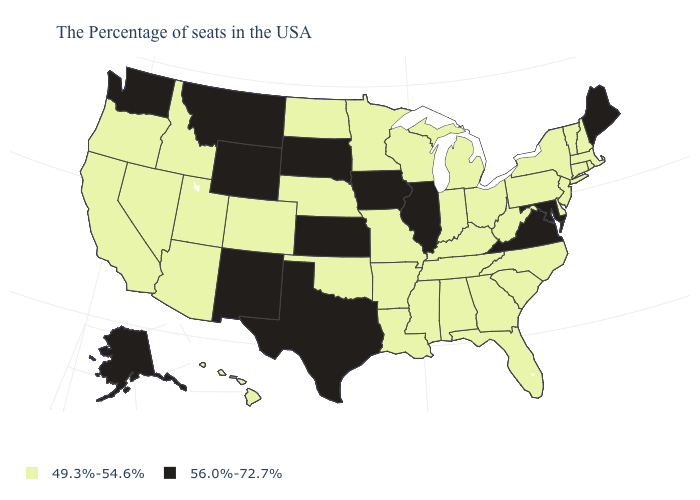What is the lowest value in states that border Kansas?
Short answer required. 49.3%-54.6%. Which states have the lowest value in the USA?
Give a very brief answer. Massachusetts, Rhode Island, New Hampshire, Vermont, Connecticut, New York, New Jersey, Delaware, Pennsylvania, North Carolina, South Carolina, West Virginia, Ohio, Florida, Georgia, Michigan, Kentucky, Indiana, Alabama, Tennessee, Wisconsin, Mississippi, Louisiana, Missouri, Arkansas, Minnesota, Nebraska, Oklahoma, North Dakota, Colorado, Utah, Arizona, Idaho, Nevada, California, Oregon, Hawaii. What is the value of Rhode Island?
Keep it brief. 49.3%-54.6%. Does Wyoming have the highest value in the West?
Answer briefly. Yes. Does Wisconsin have the highest value in the USA?
Concise answer only. No. Does the first symbol in the legend represent the smallest category?
Write a very short answer. Yes. Name the states that have a value in the range 56.0%-72.7%?
Answer briefly. Maine, Maryland, Virginia, Illinois, Iowa, Kansas, Texas, South Dakota, Wyoming, New Mexico, Montana, Washington, Alaska. Name the states that have a value in the range 49.3%-54.6%?
Answer briefly. Massachusetts, Rhode Island, New Hampshire, Vermont, Connecticut, New York, New Jersey, Delaware, Pennsylvania, North Carolina, South Carolina, West Virginia, Ohio, Florida, Georgia, Michigan, Kentucky, Indiana, Alabama, Tennessee, Wisconsin, Mississippi, Louisiana, Missouri, Arkansas, Minnesota, Nebraska, Oklahoma, North Dakota, Colorado, Utah, Arizona, Idaho, Nevada, California, Oregon, Hawaii. What is the lowest value in the South?
Concise answer only. 49.3%-54.6%. Name the states that have a value in the range 49.3%-54.6%?
Concise answer only. Massachusetts, Rhode Island, New Hampshire, Vermont, Connecticut, New York, New Jersey, Delaware, Pennsylvania, North Carolina, South Carolina, West Virginia, Ohio, Florida, Georgia, Michigan, Kentucky, Indiana, Alabama, Tennessee, Wisconsin, Mississippi, Louisiana, Missouri, Arkansas, Minnesota, Nebraska, Oklahoma, North Dakota, Colorado, Utah, Arizona, Idaho, Nevada, California, Oregon, Hawaii. Which states have the lowest value in the Northeast?
Write a very short answer. Massachusetts, Rhode Island, New Hampshire, Vermont, Connecticut, New York, New Jersey, Pennsylvania. Name the states that have a value in the range 49.3%-54.6%?
Concise answer only. Massachusetts, Rhode Island, New Hampshire, Vermont, Connecticut, New York, New Jersey, Delaware, Pennsylvania, North Carolina, South Carolina, West Virginia, Ohio, Florida, Georgia, Michigan, Kentucky, Indiana, Alabama, Tennessee, Wisconsin, Mississippi, Louisiana, Missouri, Arkansas, Minnesota, Nebraska, Oklahoma, North Dakota, Colorado, Utah, Arizona, Idaho, Nevada, California, Oregon, Hawaii. What is the value of Louisiana?
Be succinct. 49.3%-54.6%. Which states have the highest value in the USA?
Concise answer only. Maine, Maryland, Virginia, Illinois, Iowa, Kansas, Texas, South Dakota, Wyoming, New Mexico, Montana, Washington, Alaska. Name the states that have a value in the range 56.0%-72.7%?
Concise answer only. Maine, Maryland, Virginia, Illinois, Iowa, Kansas, Texas, South Dakota, Wyoming, New Mexico, Montana, Washington, Alaska. 